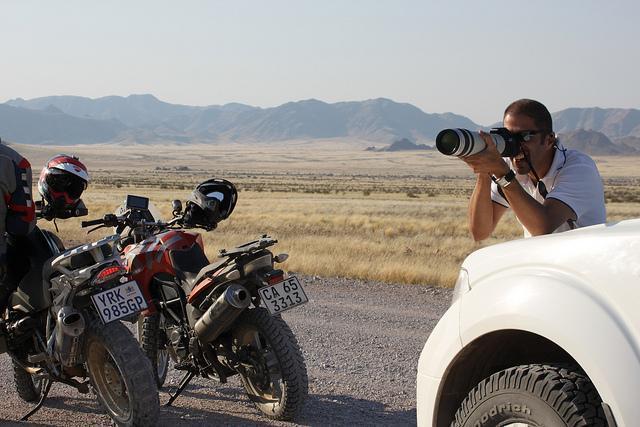How far away is the item being photographed?
Indicate the correct response and explain using: 'Answer: answer
Rationale: rationale.'
Options: 2 feet, 10 feet, behind photographer, very far. Answer: very far.
Rationale: The cameraman has a zoom lens which means the item is not near to him. 